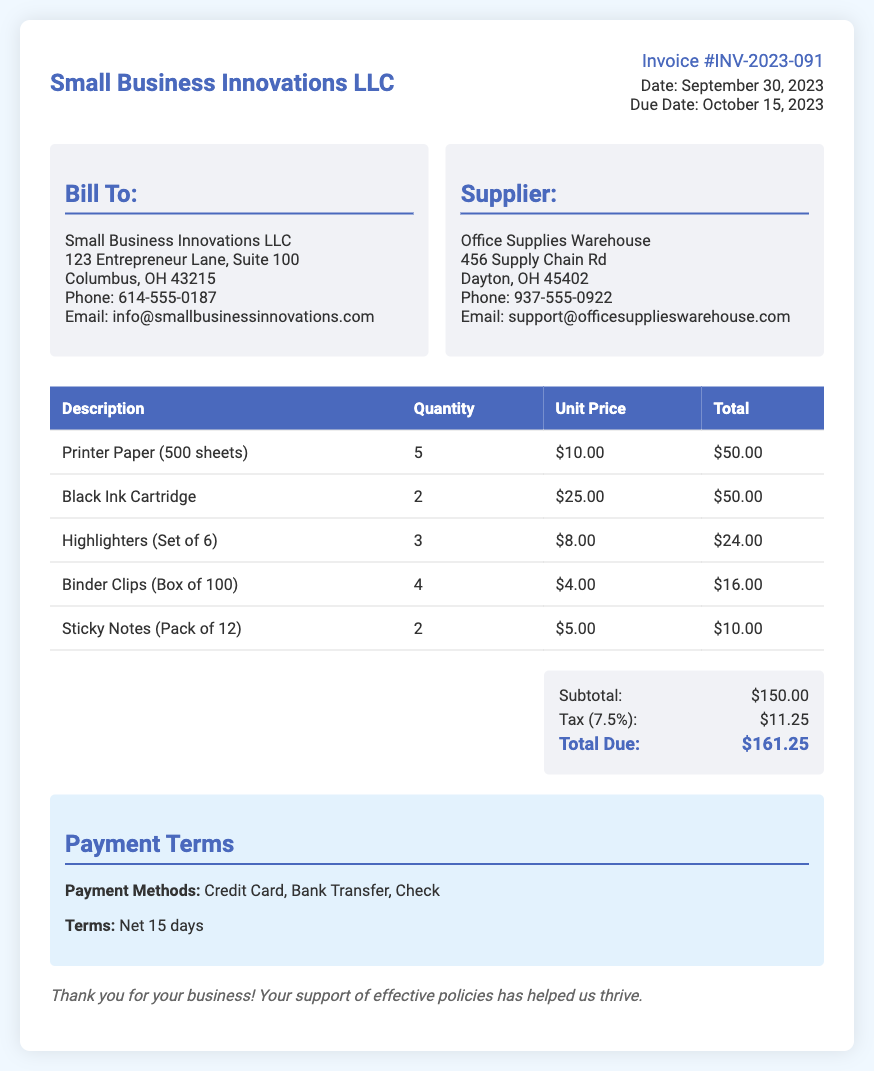What is the invoice number? The invoice number is listed at the top right of the document under the invoice details section.
Answer: INV-2023-091 What is the due date for the payment? The due date is mentioned in the invoice details section along with the invoice date.
Answer: October 15, 2023 How much is the tax charged? The tax amount is provided in the total section of the document as a separate line item.
Answer: $11.25 What is the total due amount? The total due amount is also listed in the total section, summarizing all charges including tax.
Answer: $161.25 How many units of Printer Paper were purchased? The quantity of Printer Paper is given in the itemized list of products on the invoice.
Answer: 5 Which item has the highest unit price? The item with the highest unit price can be identified by looking at the unit prices in the itemized list.
Answer: Black Ink Cartridge What payment methods are accepted? Accepted payment methods are specified in the payment terms section of the document.
Answer: Credit Card, Bank Transfer, Check What is the subtotal before tax? The subtotal is indicated in the total section of the document before tax is applied.
Answer: $150.00 What is the company name of the supplier? The supplier's name is shown in the addresses section, specifically under the supplier box.
Answer: Office Supplies Warehouse 